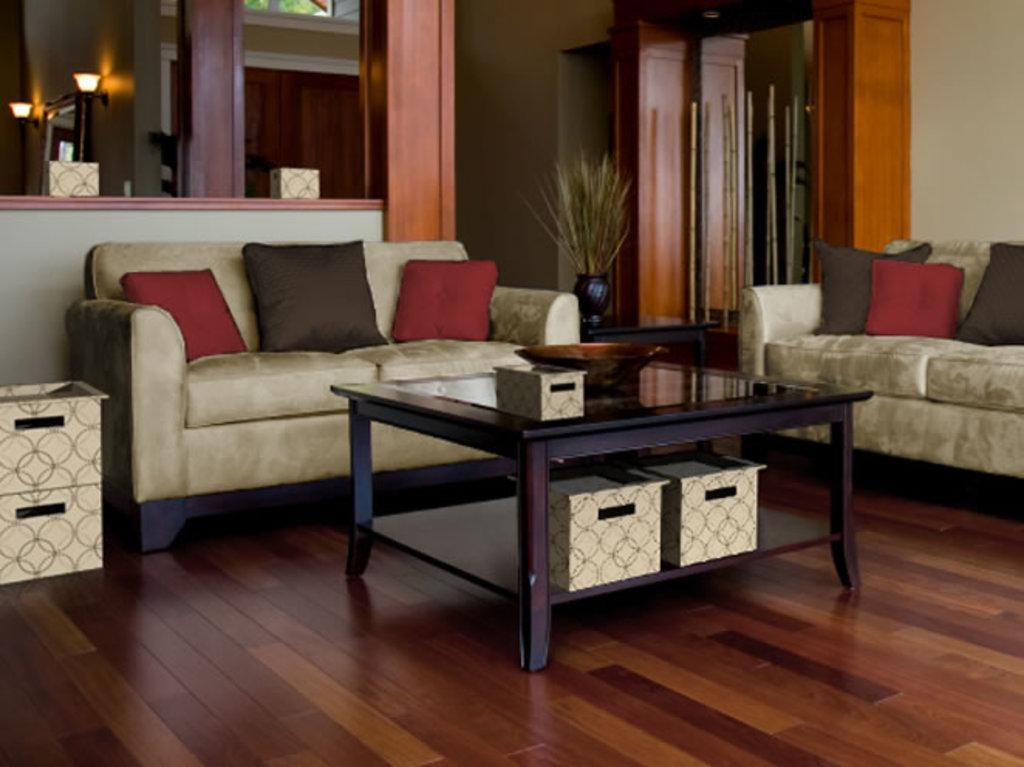What type of space is depicted in the image? There is a room in the image. What furniture is present in the room? There is a table and a sofa in the room. What is on the table? There is a bowl on the table. What is on the sofa? There is a pillow on the sofa. What can be seen in the background of the room? In the background, there are wooden sticks, a wall, a cupboard, and a house plant. How many legs does the tooth have in the image? There is no tooth present in the image, so it is not possible to determine how many legs it might have. 